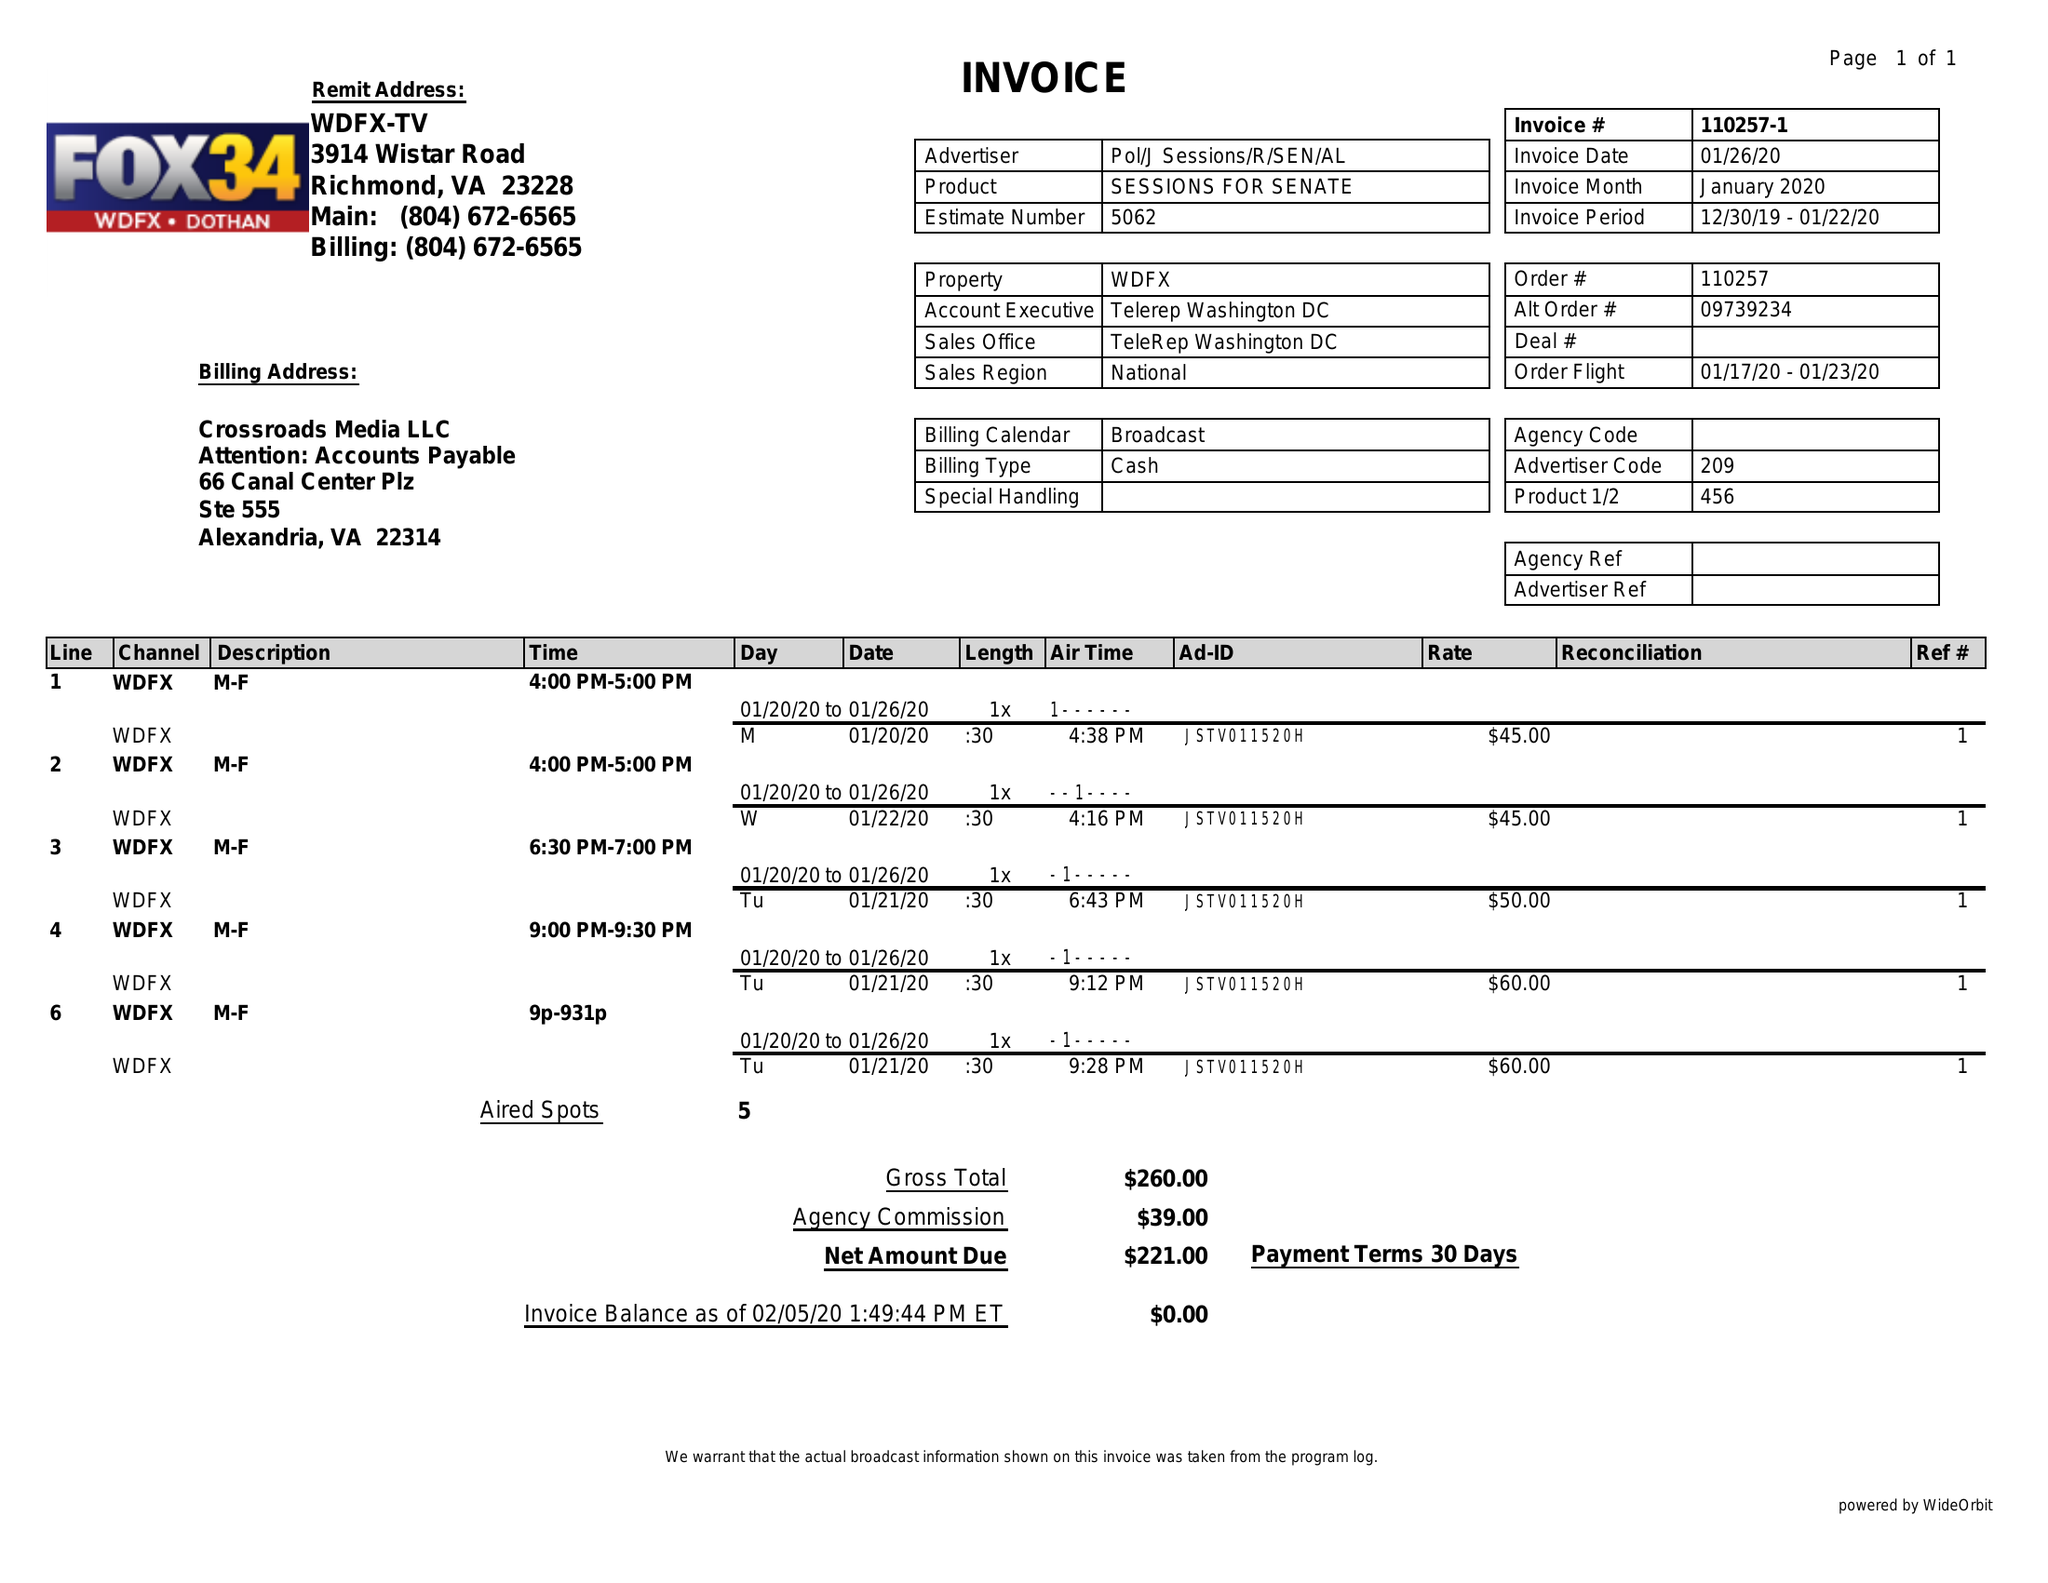What is the value for the flight_from?
Answer the question using a single word or phrase. 01/17/20 